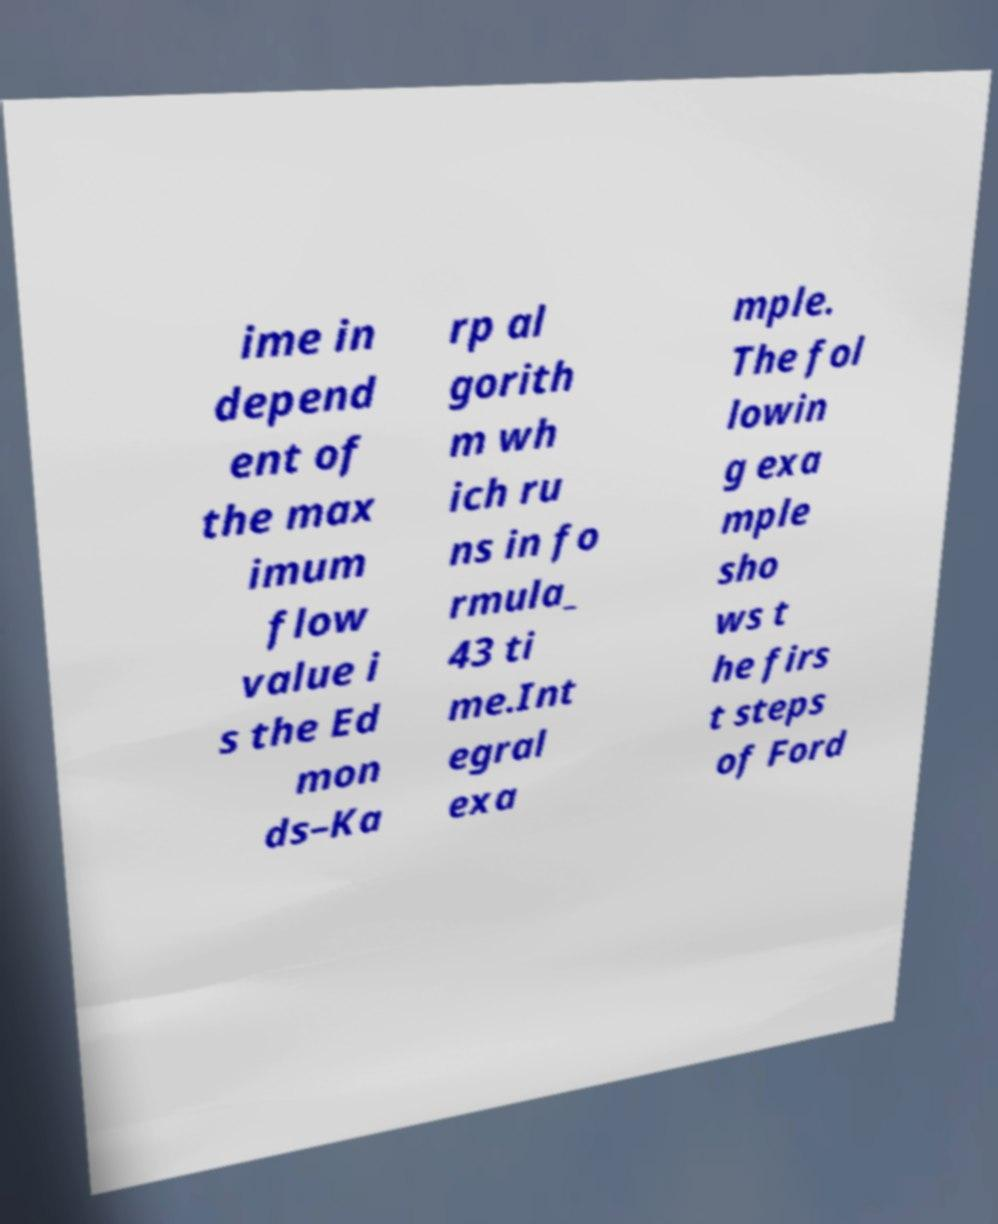Please read and relay the text visible in this image. What does it say? ime in depend ent of the max imum flow value i s the Ed mon ds–Ka rp al gorith m wh ich ru ns in fo rmula_ 43 ti me.Int egral exa mple. The fol lowin g exa mple sho ws t he firs t steps of Ford 